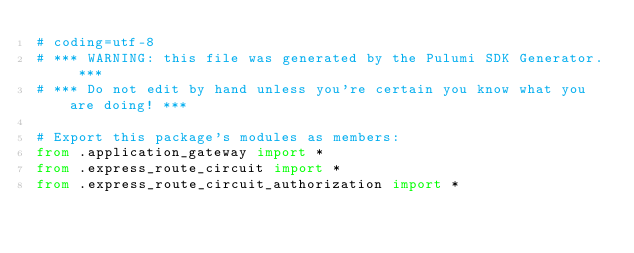<code> <loc_0><loc_0><loc_500><loc_500><_Python_># coding=utf-8
# *** WARNING: this file was generated by the Pulumi SDK Generator. ***
# *** Do not edit by hand unless you're certain you know what you are doing! ***

# Export this package's modules as members:
from .application_gateway import *
from .express_route_circuit import *
from .express_route_circuit_authorization import *</code> 